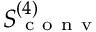<formula> <loc_0><loc_0><loc_500><loc_500>S _ { c o n v } ^ { ( 4 ) }</formula> 